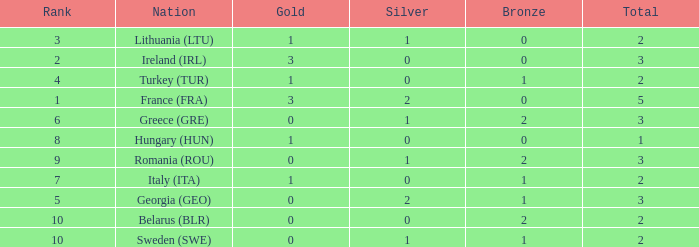Give me the full table as a dictionary. {'header': ['Rank', 'Nation', 'Gold', 'Silver', 'Bronze', 'Total'], 'rows': [['3', 'Lithuania (LTU)', '1', '1', '0', '2'], ['2', 'Ireland (IRL)', '3', '0', '0', '3'], ['4', 'Turkey (TUR)', '1', '0', '1', '2'], ['1', 'France (FRA)', '3', '2', '0', '5'], ['6', 'Greece (GRE)', '0', '1', '2', '3'], ['8', 'Hungary (HUN)', '1', '0', '0', '1'], ['9', 'Romania (ROU)', '0', '1', '2', '3'], ['7', 'Italy (ITA)', '1', '0', '1', '2'], ['5', 'Georgia (GEO)', '0', '2', '1', '3'], ['10', 'Belarus (BLR)', '0', '0', '2', '2'], ['10', 'Sweden (SWE)', '0', '1', '1', '2']]} What's the total of Sweden (SWE) having less than 1 silver? None. 